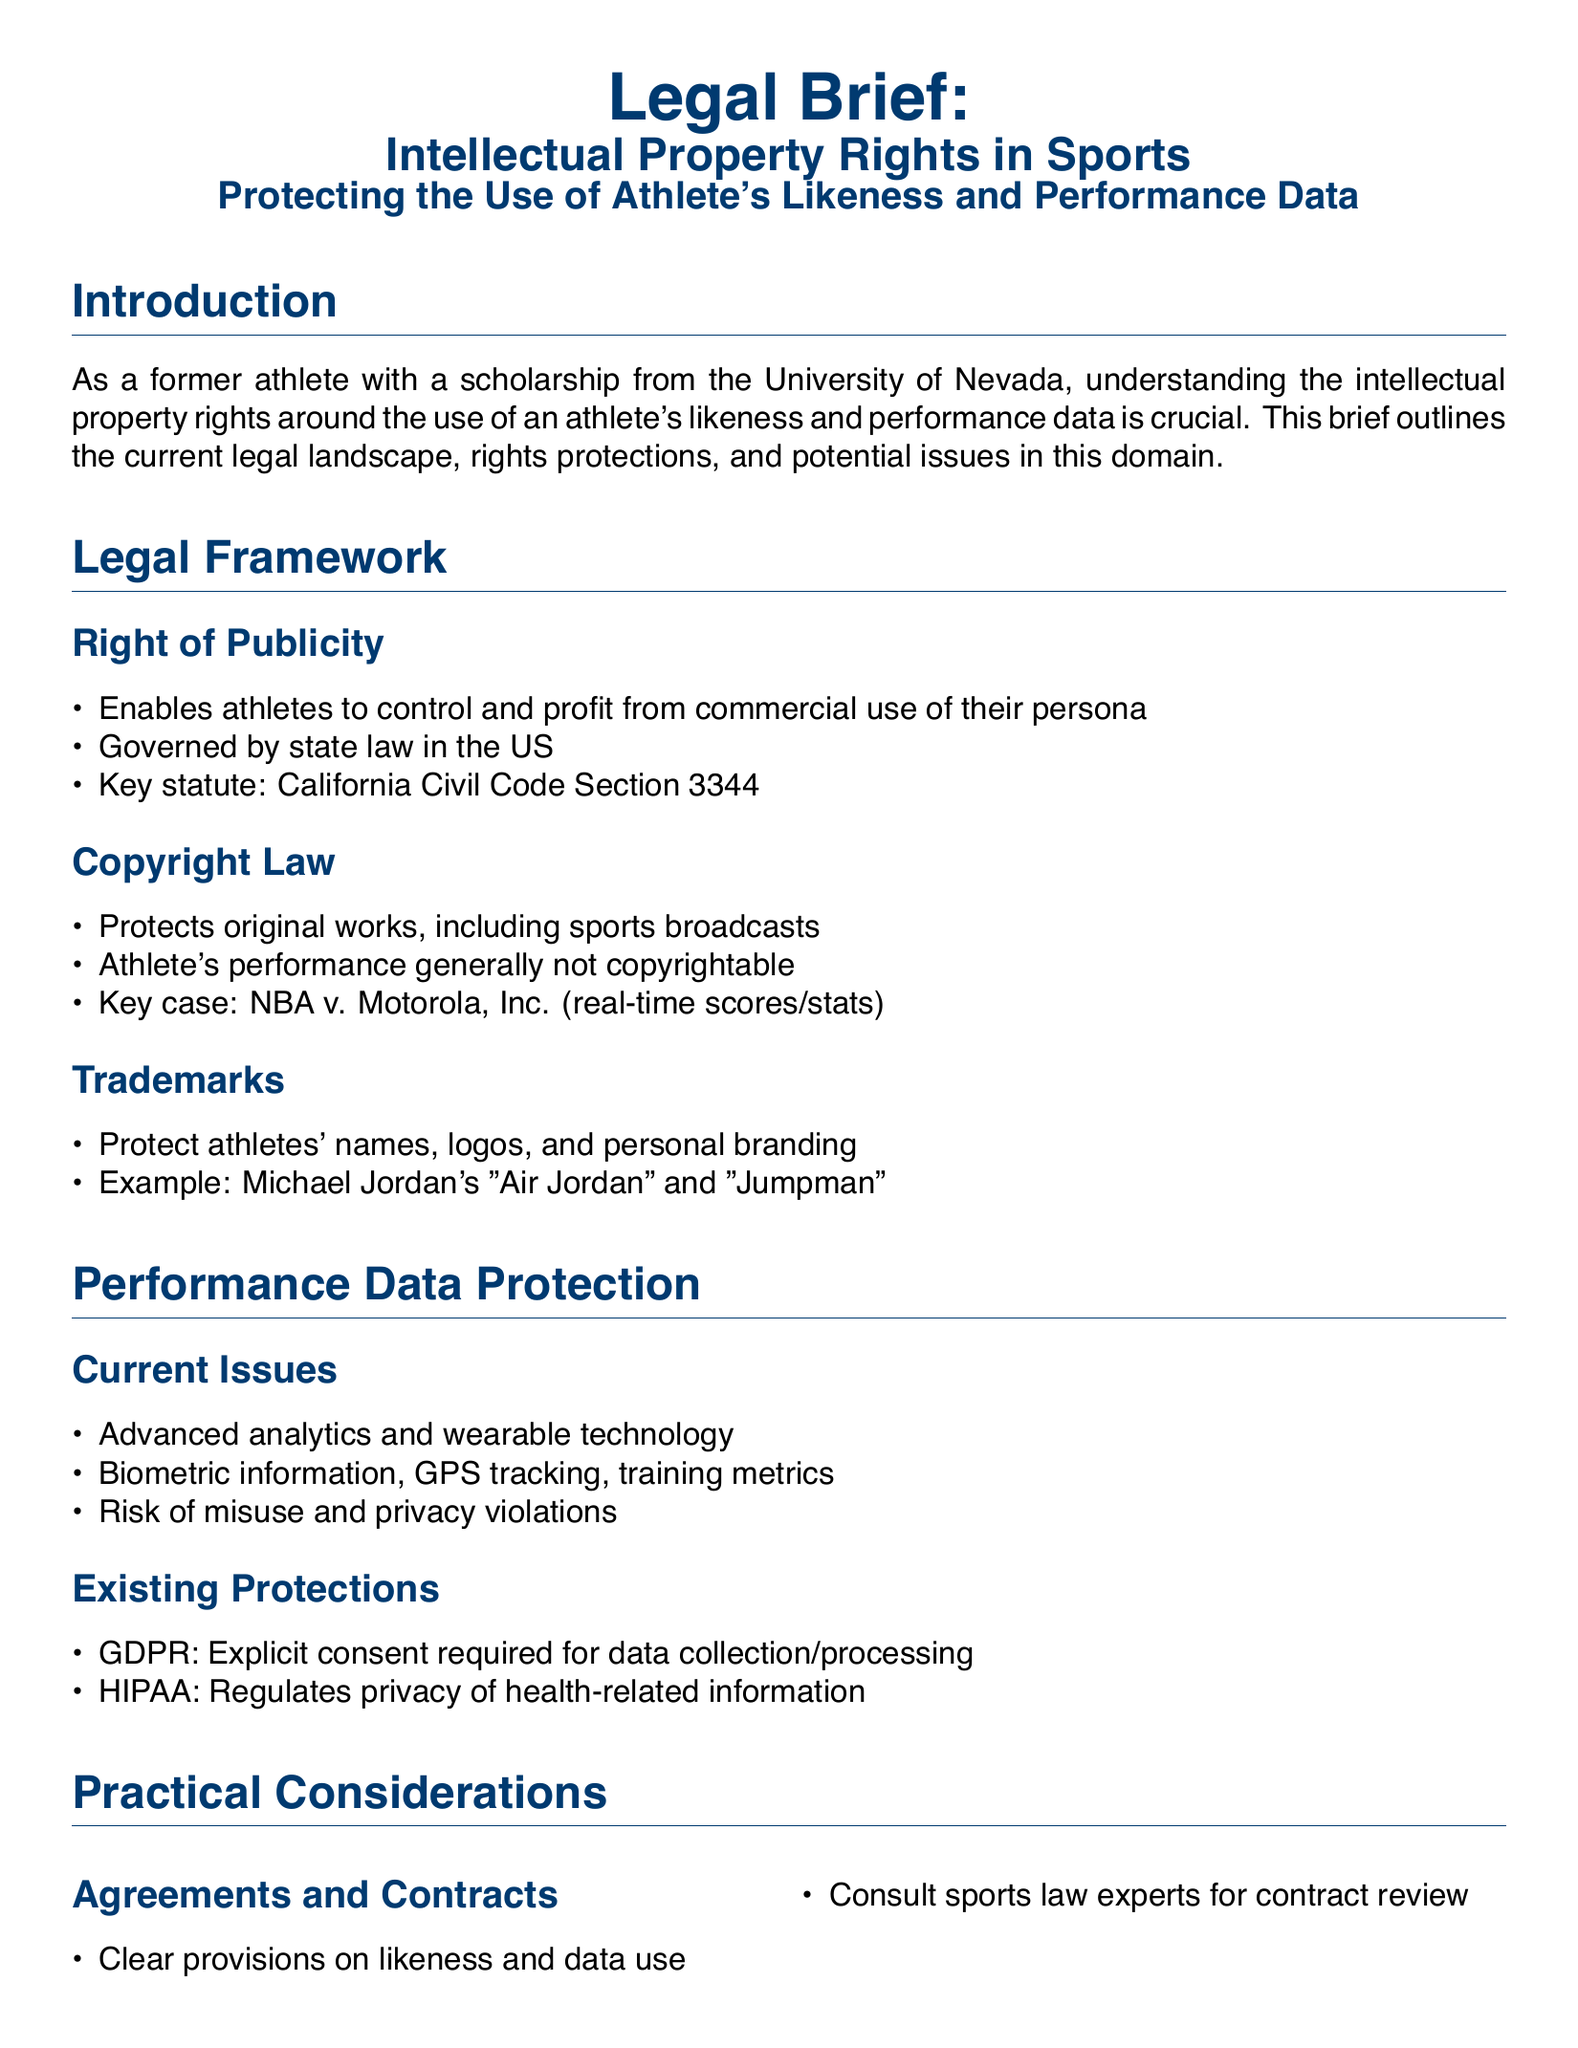what is the key statute for the right of publicity in California? The document explicitly states that the key statute is California Civil Code Section 3344.
Answer: California Civil Code Section 3344 what protects original works, including sports broadcasts? The section on copyright law indicates that copyright law protects original works.
Answer: Copyright law what does GDPR require for data collection? The existing protections state that GDPR requires explicit consent for data collection and processing.
Answer: Explicit consent which athlete's branding is mentioned as an example of trademark protection? The document provides the example of Michael Jordan's "Air Jordan" and "Jumpman" under trademarks.
Answer: Michael Jordan's "Air Jordan" and "Jumpman" which law regulates the privacy of health-related information? The existing protections mention HIPAA as the law regulating privacy of health-related information.
Answer: HIPAA what emerging technology is suggested for secure rights management? The document suggests blockchain as an emerging technology for secure rights management.
Answer: Blockchain what type of agreements should athletes consult sports law experts for? The document states that athletes should consult sports law experts for agreements related to likeness and data use.
Answer: Agreements related to likeness and data use what two factors are crucial in protecting intellectual property rights in sports? The conclusion highlights that securing rights through appropriate legal channels and safeguarding personal information are crucial.
Answer: Securing rights and safeguarding personal information what technology provides potential for improved transparency and control? The emerging technologies section mentions DRM as a technology providing potential for improved transparency and control.
Answer: DRM 